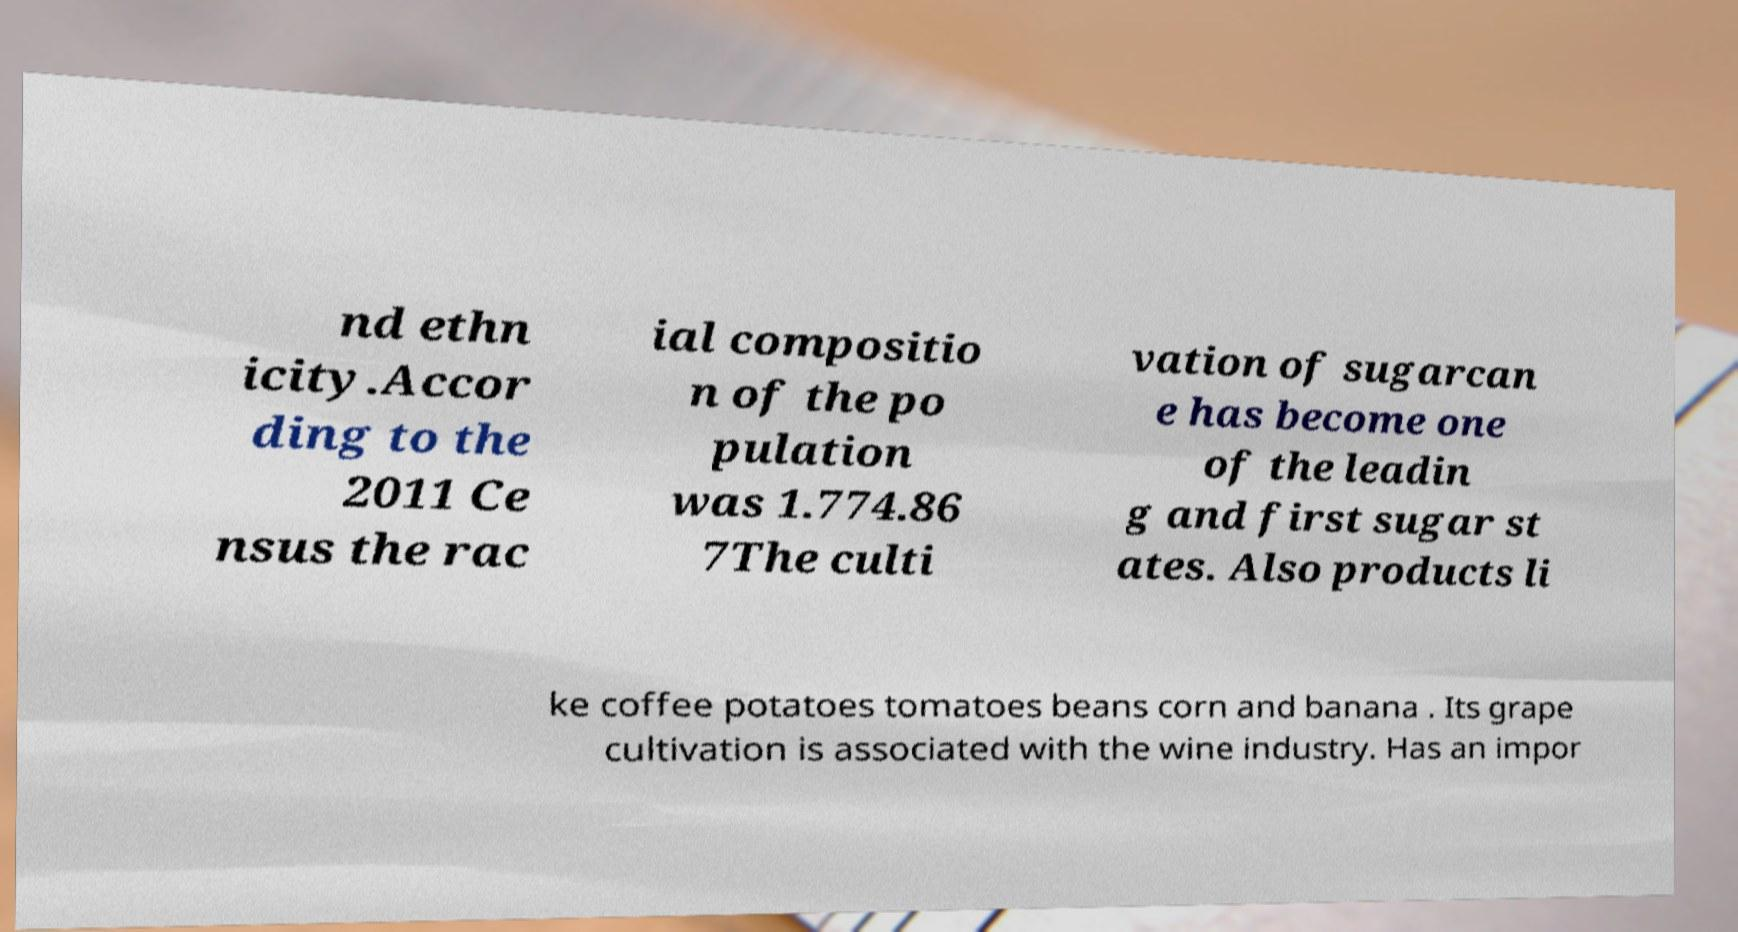I need the written content from this picture converted into text. Can you do that? nd ethn icity.Accor ding to the 2011 Ce nsus the rac ial compositio n of the po pulation was 1.774.86 7The culti vation of sugarcan e has become one of the leadin g and first sugar st ates. Also products li ke coffee potatoes tomatoes beans corn and banana . Its grape cultivation is associated with the wine industry. Has an impor 